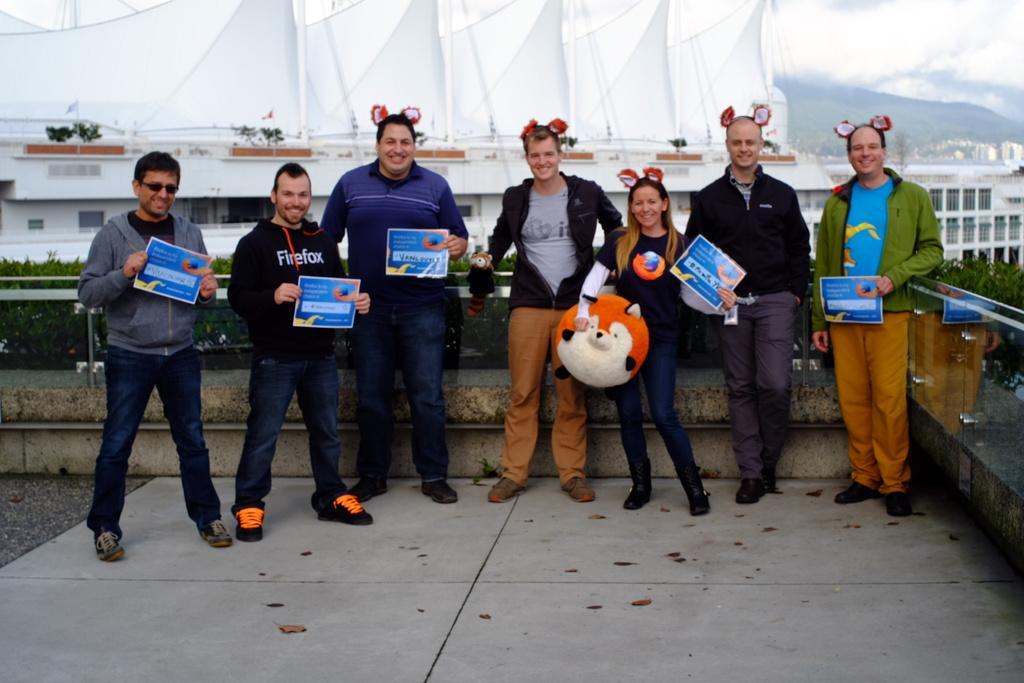Could you give a brief overview of what you see in this image? In this image there are a few people standing with a smile on their face and they are holding some posters with text on it, one of them is holding a toy in her hand, behind them there is a wall with glass and plants. In the background there are buildings, mountains and the sky. 